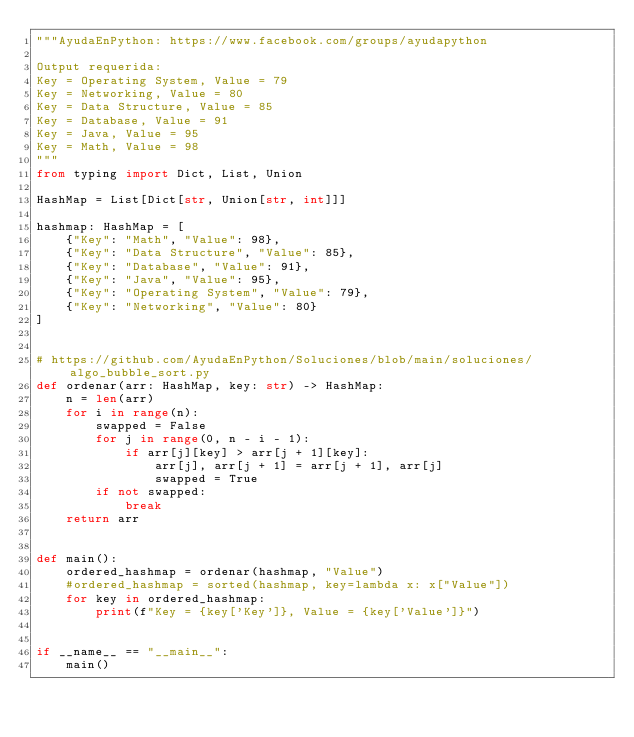<code> <loc_0><loc_0><loc_500><loc_500><_Python_>"""AyudaEnPython: https://www.facebook.com/groups/ayudapython

Output requerida:
Key = Operating System, Value = 79
Key = Networking, Value = 80
Key = Data Structure, Value = 85
Key = Database, Value = 91
Key = Java, Value = 95
Key = Math, Value = 98
"""
from typing import Dict, List, Union

HashMap = List[Dict[str, Union[str, int]]]

hashmap: HashMap = [
    {"Key": "Math", "Value": 98},
    {"Key": "Data Structure", "Value": 85},
    {"Key": "Database", "Value": 91},
    {"Key": "Java", "Value": 95},
    {"Key": "Operating System", "Value": 79},
    {"Key": "Networking", "Value": 80}
]


# https://github.com/AyudaEnPython/Soluciones/blob/main/soluciones/algo_bubble_sort.py
def ordenar(arr: HashMap, key: str) -> HashMap:
    n = len(arr)
    for i in range(n):
        swapped = False
        for j in range(0, n - i - 1):
            if arr[j][key] > arr[j + 1][key]:
                arr[j], arr[j + 1] = arr[j + 1], arr[j]
                swapped = True
        if not swapped:
            break
    return arr


def main():
    ordered_hashmap = ordenar(hashmap, "Value")
    #ordered_hashmap = sorted(hashmap, key=lambda x: x["Value"])
    for key in ordered_hashmap:
        print(f"Key = {key['Key']}, Value = {key['Value']}")


if __name__ == "__main__":
    main()
</code> 